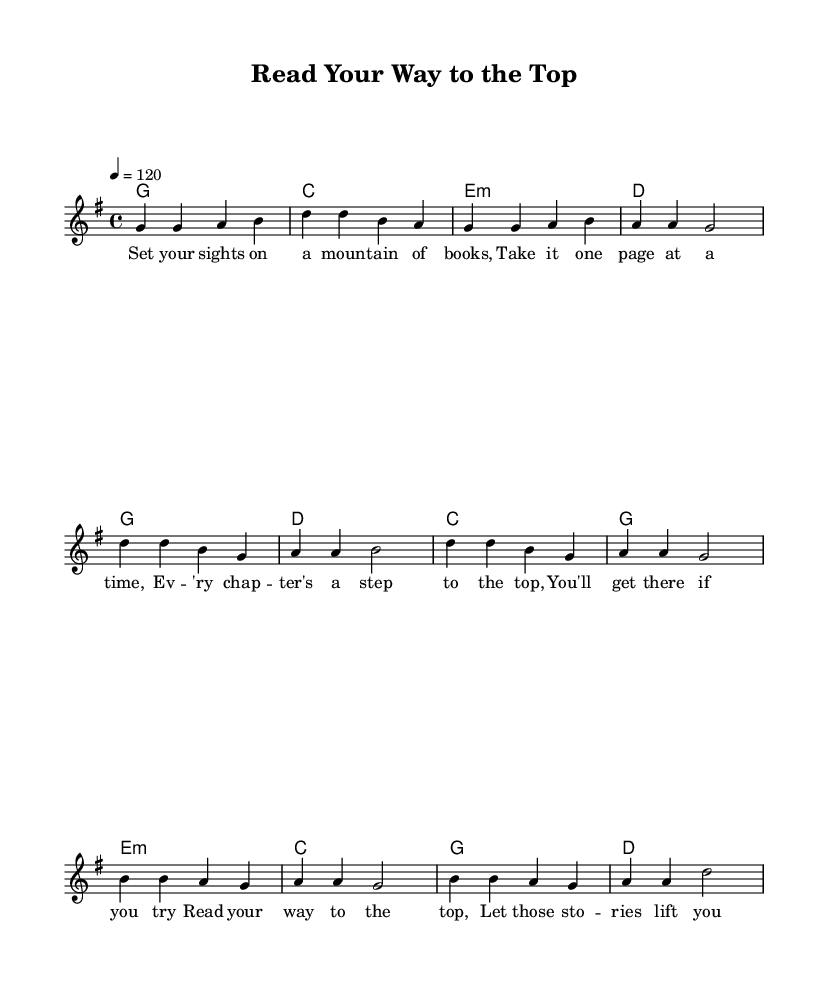What is the key signature of this music? The key signature is G major, which has one sharp (F#). This can be determined by looking at the key signature indicated at the beginning of the score.
Answer: G major What is the time signature of this piece? The time signature is 4/4, shown at the start of the piece indicating four beats per measure and a quarter note gets one beat.
Answer: 4/4 What is the tempo marking for this piece? The tempo is marked as quarter note equals 120, which signifies the speed at which the music should be played. This marking is indicated near the beginning of the score.
Answer: 120 How many measures are in the chorus? The chorus consists of four measures, which can be counted by identifying the grouping of the notes and bars within the chorus section.
Answer: 4 What is the main theme of the lyrics in the chorus? The main theme of the chorus revolves around perseverance in achieving reading goals, as it mentions "set your goals" and "don't you stop." This highlights a motivational perspective related to reading.
Answer: Perseverance What is the structure of the song? The song structure contains three sections: a verse, a chorus, and a bridge, which are commonly found in country rock music. This can be inferred by the labeling in the respective sections.
Answer: Verse, Chorus, Bridge What is the mood conveyed by this country rock piece? The mood is motivational and uplifting, as the lyrics encourage readers to set and achieve their personal goals, emphasizing determination and reaching new heights.
Answer: Motivational 